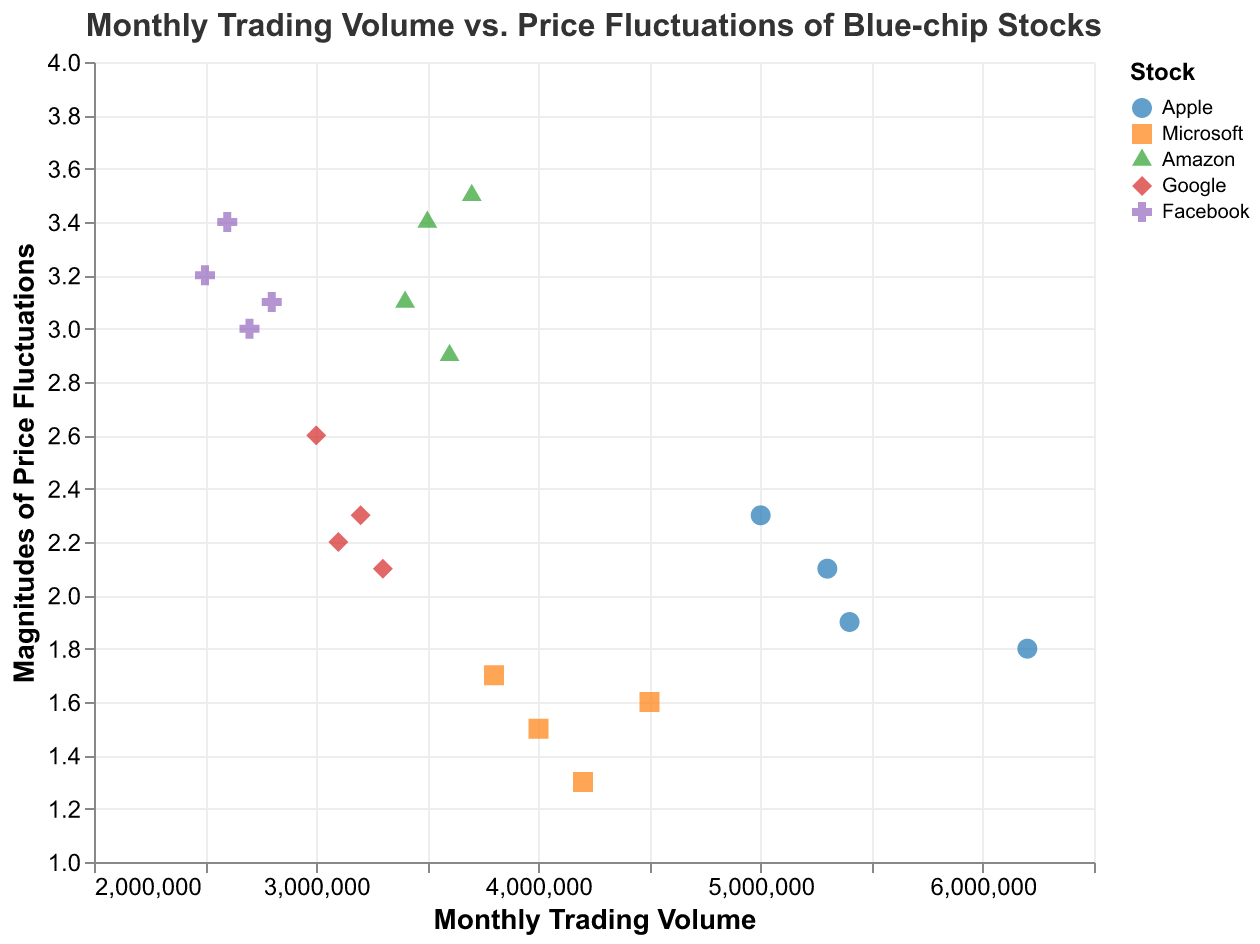What is the trading volume range for all stocks in the plot? By examining the x-axis, we see that the trading volume ranges from the minimum to the maximum plotted values, which are approximately 2,500,000 to 6,200,000.
Answer: 2,500,000 to 6,200,000 Which stock shows the highest magnitude of price fluctuations? In the plot, Amazon is represented with the highest points on the y-axis, indicating the highest magnitude of price fluctuations.
Answer: Amazon How does the trading volume of Apple compare to that of Google on average? To determine this, calculate the average trading volume for each stock. Apple's volumes are 5,000,000, 6,200,000, 5,300,000, and 5,400,000, averaging to 5,475,000; Google’s volumes are 3,100,000, 3,000,000, 3,300,000, and 3,200,000, averaging to 3,150,000. Therefore, Apple has a significantly higher average trading volume than Google.
Answer: Apple has a higher average trading volume Are there any stocks that show a negative correlation between trading volume and price fluctuation? Looking at the plot, Microsoft shows a pattern where higher trading volume points are generally associated with lower price fluctuations, indicating a negative correlation.
Answer: Microsoft Which stock has the most consistent trading volume, and what is its range? Both Google and Facebook have relatively consistent trading volumes, but Google has a narrower range (3,000,000 to 3,300,000) compared to Facebook (2,500,000 to 2,800,000). Google is the most consistent.
Answer: Google, 3,000,000 to 3,300,000 What is the biggest price fluctuation observed for Facebook, and at what trading volume? By looking at Facebook's points on the plot, the biggest price fluctuation (3.4) occurs at a trading volume of 2,600,000.
Answer: 3.4 at 2,600,000 Does a higher trading volume always correspond to lower price fluctuations for any of the stocks? For Apple, as the trading volume increases, the magnitude of price fluctuation generally decreases, suggesting a trend where higher volumes correspond to lower price fluctuations.
Answer: Apple What is the average magnitude of price fluctuations for Amazon? Calculate the average of Amazon’s price fluctuations: (3.4 + 2.9 + 3.1 + 3.5) / 4 = 3.225.
Answer: 3.225 Which stock has the lowest trading volume, and what is the corresponding price fluctuation? The lowest trading volume point is 2,500,000 for Facebook, with a corresponding price fluctuation of 3.2.
Answer: Facebook, 3.2 